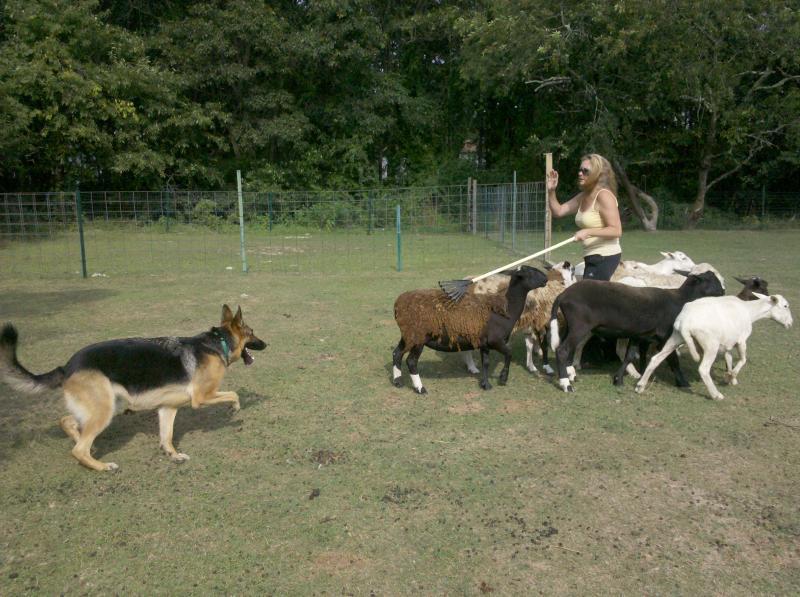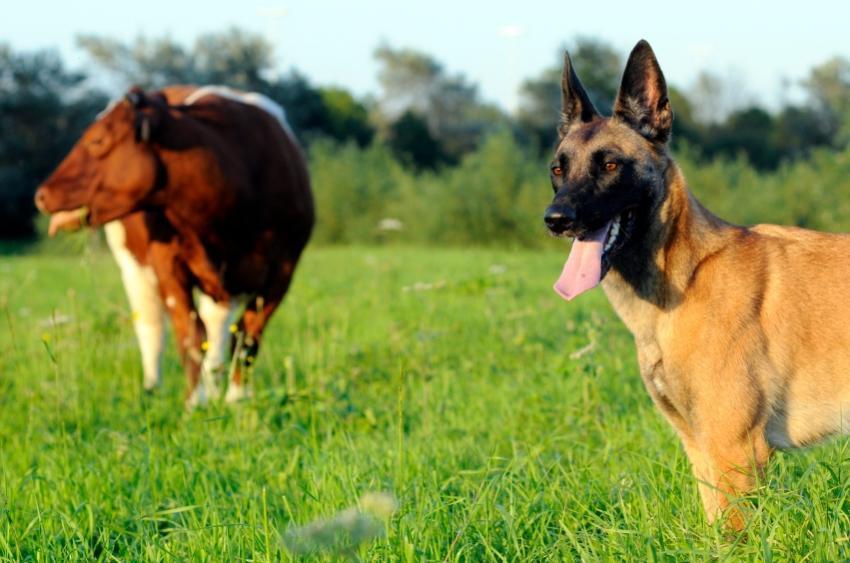The first image is the image on the left, the second image is the image on the right. Assess this claim about the two images: "There are no more than two animals in the image on the right.". Correct or not? Answer yes or no. Yes. 